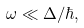Convert formula to latex. <formula><loc_0><loc_0><loc_500><loc_500>\omega \ll \Delta / \hbar { , }</formula> 